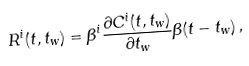Convert formula to latex. <formula><loc_0><loc_0><loc_500><loc_500>R ^ { i } ( t , t _ { w } ) = \beta ^ { i } \frac { \partial C ^ { i } ( t , t _ { w } ) } { \partial t _ { w } } \Theta ( t - t _ { w } ) \, ,</formula> 